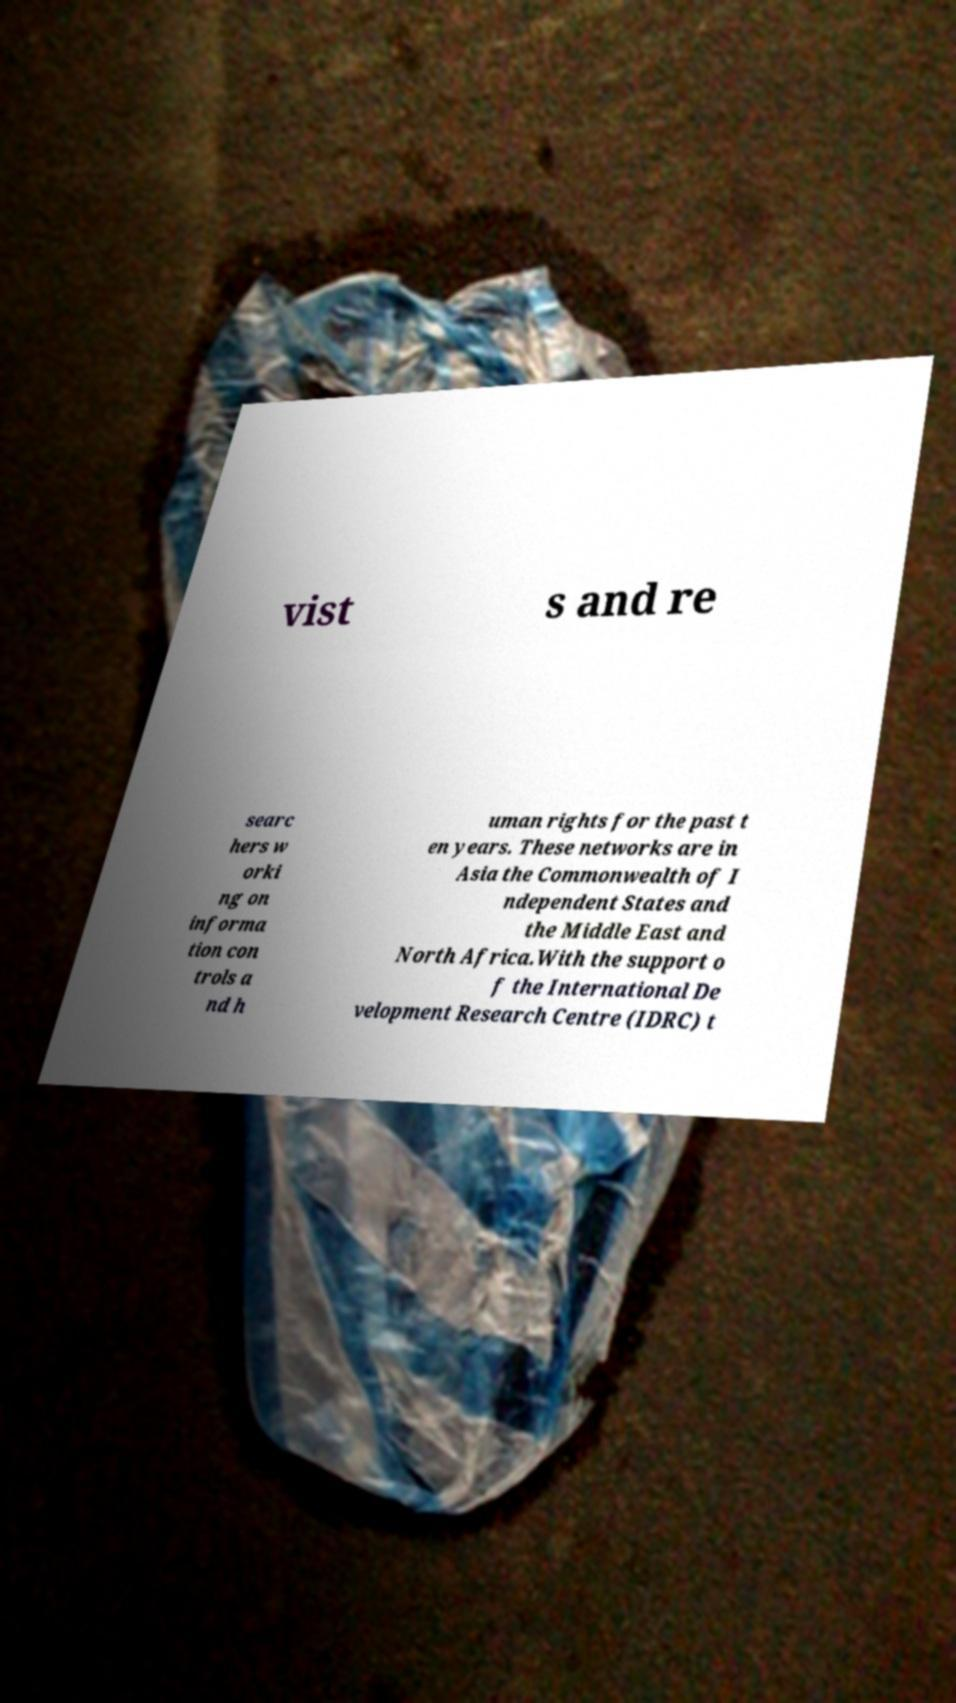Can you accurately transcribe the text from the provided image for me? vist s and re searc hers w orki ng on informa tion con trols a nd h uman rights for the past t en years. These networks are in Asia the Commonwealth of I ndependent States and the Middle East and North Africa.With the support o f the International De velopment Research Centre (IDRC) t 